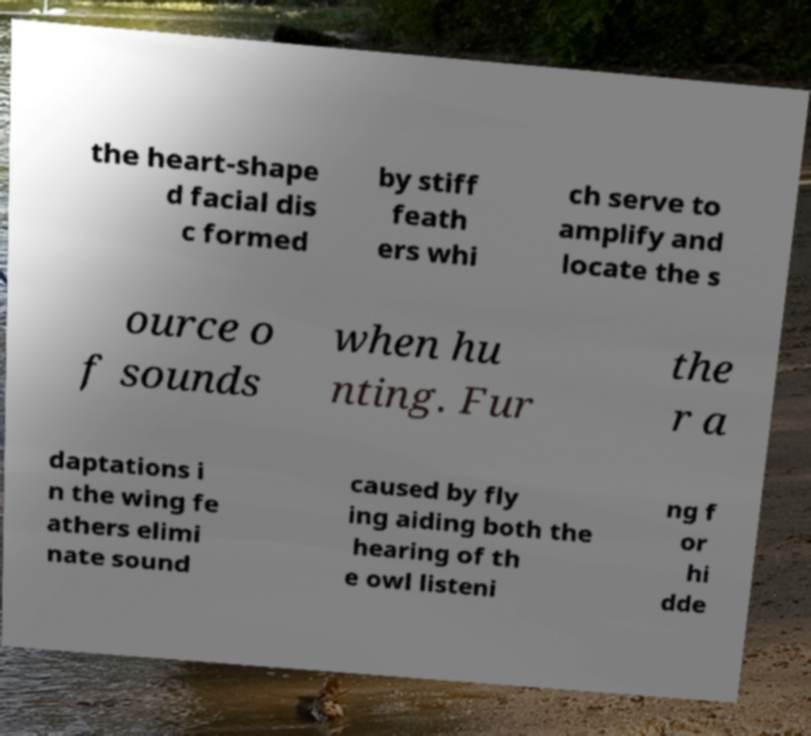Can you read and provide the text displayed in the image?This photo seems to have some interesting text. Can you extract and type it out for me? the heart-shape d facial dis c formed by stiff feath ers whi ch serve to amplify and locate the s ource o f sounds when hu nting. Fur the r a daptations i n the wing fe athers elimi nate sound caused by fly ing aiding both the hearing of th e owl listeni ng f or hi dde 